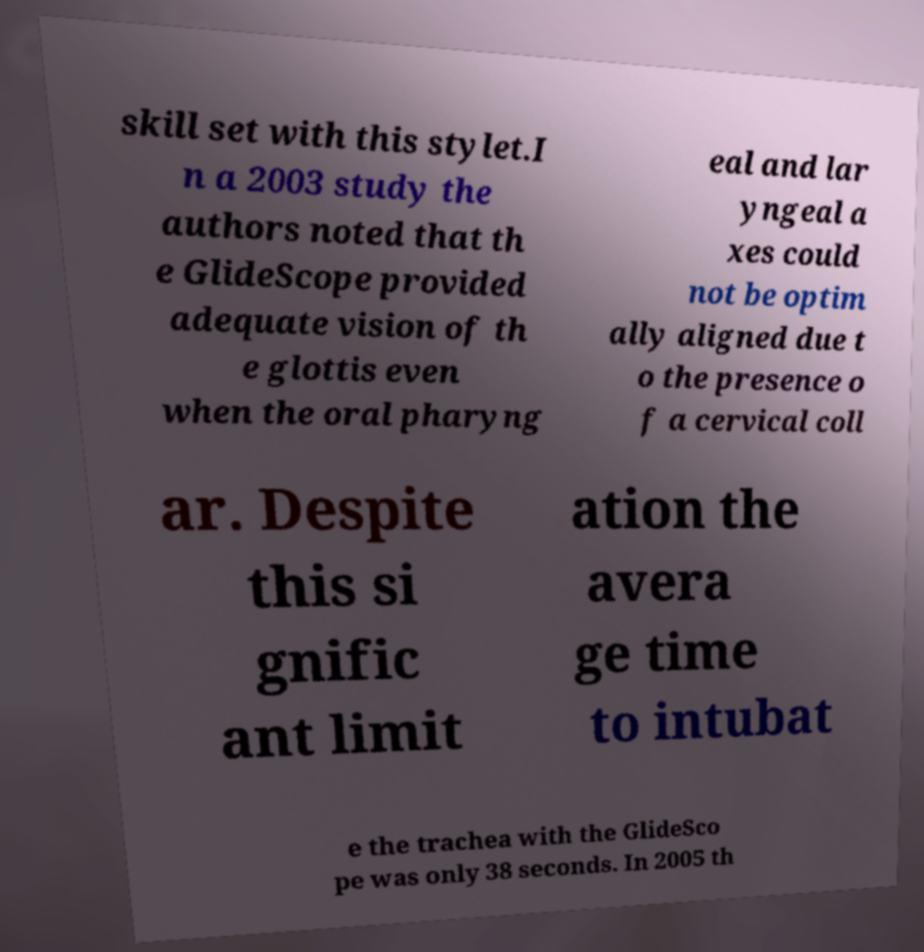For documentation purposes, I need the text within this image transcribed. Could you provide that? skill set with this stylet.I n a 2003 study the authors noted that th e GlideScope provided adequate vision of th e glottis even when the oral pharyng eal and lar yngeal a xes could not be optim ally aligned due t o the presence o f a cervical coll ar. Despite this si gnific ant limit ation the avera ge time to intubat e the trachea with the GlideSco pe was only 38 seconds. In 2005 th 